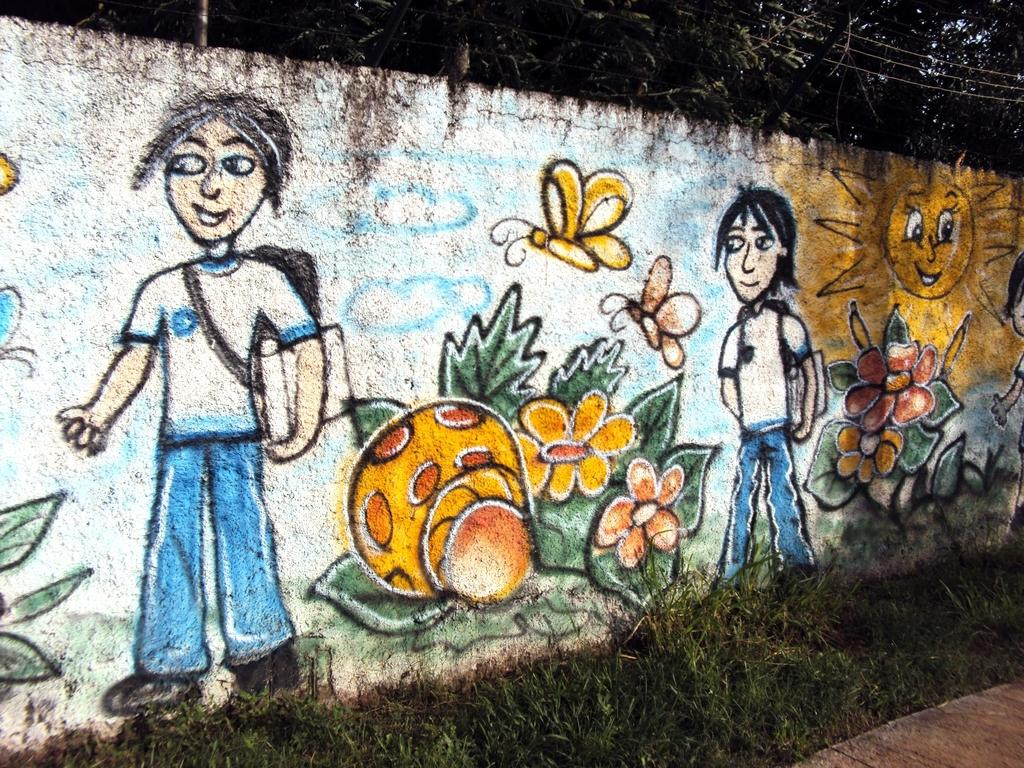What type of vegetation is present in the image? There are many trees in the image. What structure can be seen in the image? There is a pole in the image. What else is present in the image related to electricity? There are electrical cables in the image. What type of artwork is visible in the image? There is a painting on a wall in the image. What type of terrain is visible in the image? There is a grassy land in the image. Can you see a bubble floating in the image? There is no bubble present in the image. What type of support is provided by the pole in the image? The pole in the image does not provide any visible support for anything, as it is not connected to any other structures. Is there a swing hanging from the trees in the image? There is no swing present in the image. 